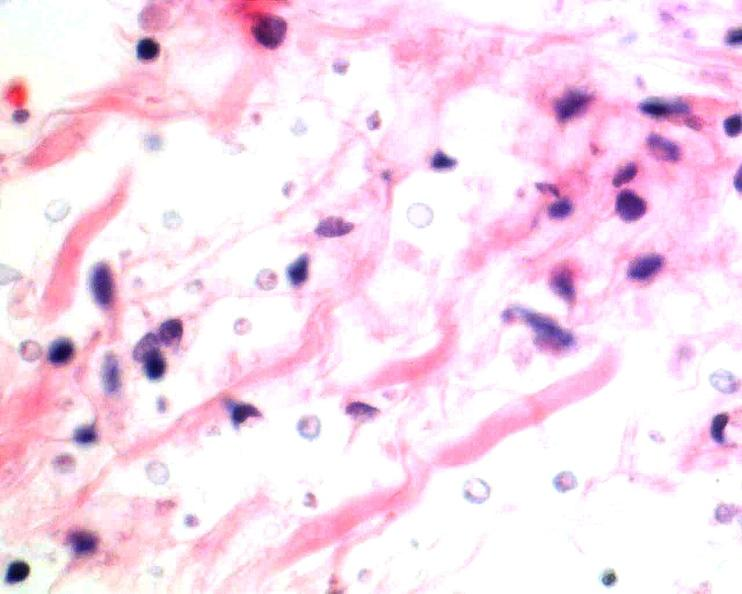where is this?
Answer the question using a single word or phrase. Nervous 